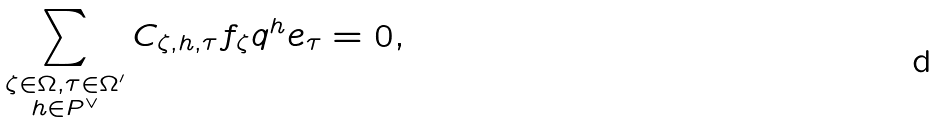Convert formula to latex. <formula><loc_0><loc_0><loc_500><loc_500>\sum _ { \substack { \zeta \in \Omega , \tau \in \Omega ^ { \prime } \\ h \in P ^ { \vee } } } C _ { \zeta , h , \tau } f _ { \zeta } q ^ { h } e _ { \tau } = 0 ,</formula> 